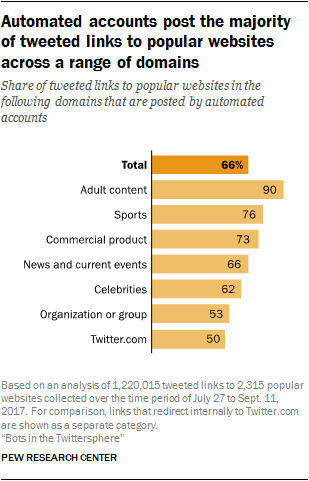Point out several critical features in this image. The ratio between the amount of adult content and Twitter.com is approximately 0.378472222... Value of Twitter.com is approximately 50. 